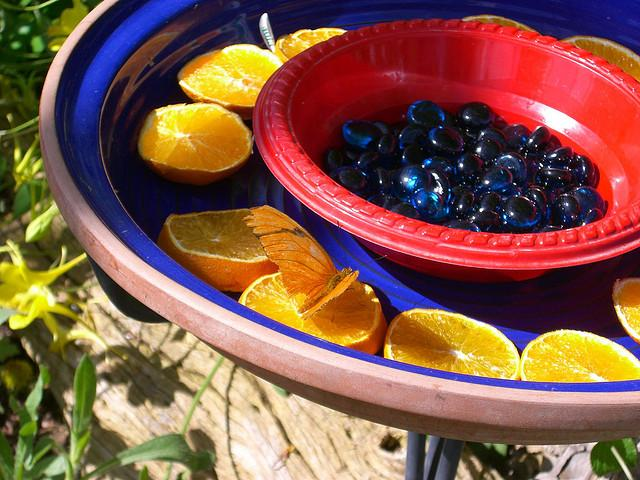What food group is being served? fruit 